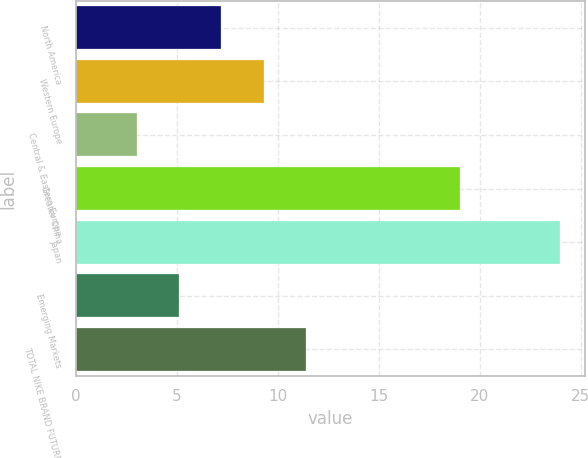<chart> <loc_0><loc_0><loc_500><loc_500><bar_chart><fcel>North America<fcel>Western Europe<fcel>Central & Eastern Europe<fcel>Greater China<fcel>Japan<fcel>Emerging Markets<fcel>TOTAL NIKE BRAND FUTURES<nl><fcel>7.2<fcel>9.3<fcel>3<fcel>19<fcel>24<fcel>5.1<fcel>11.4<nl></chart> 